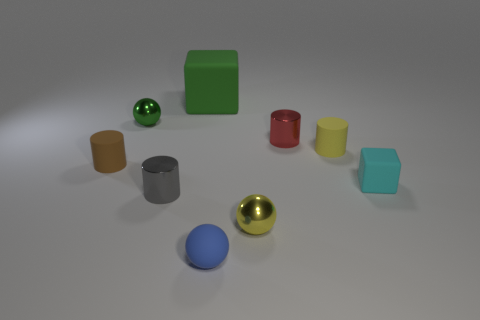Are there any other things that are the same size as the green rubber thing?
Provide a succinct answer. No. Are there any small yellow matte things that have the same shape as the brown object?
Ensure brevity in your answer.  Yes. There is a cyan object that is the same size as the yellow matte object; what shape is it?
Your response must be concise. Cube. Is the number of tiny yellow balls that are on the left side of the small yellow ball the same as the number of green balls that are on the left side of the green shiny object?
Ensure brevity in your answer.  Yes. There is a rubber object in front of the yellow object that is in front of the yellow rubber cylinder; what is its size?
Provide a succinct answer. Small. Is there another red cylinder of the same size as the red metallic cylinder?
Ensure brevity in your answer.  No. What color is the other block that is made of the same material as the big green block?
Make the answer very short. Cyan. Is the number of large red things less than the number of shiny spheres?
Offer a very short reply. Yes. There is a object that is both behind the gray cylinder and in front of the tiny brown matte cylinder; what material is it made of?
Your answer should be compact. Rubber. There is a matte cube that is to the left of the tiny matte sphere; is there a gray cylinder that is left of it?
Keep it short and to the point. Yes. 